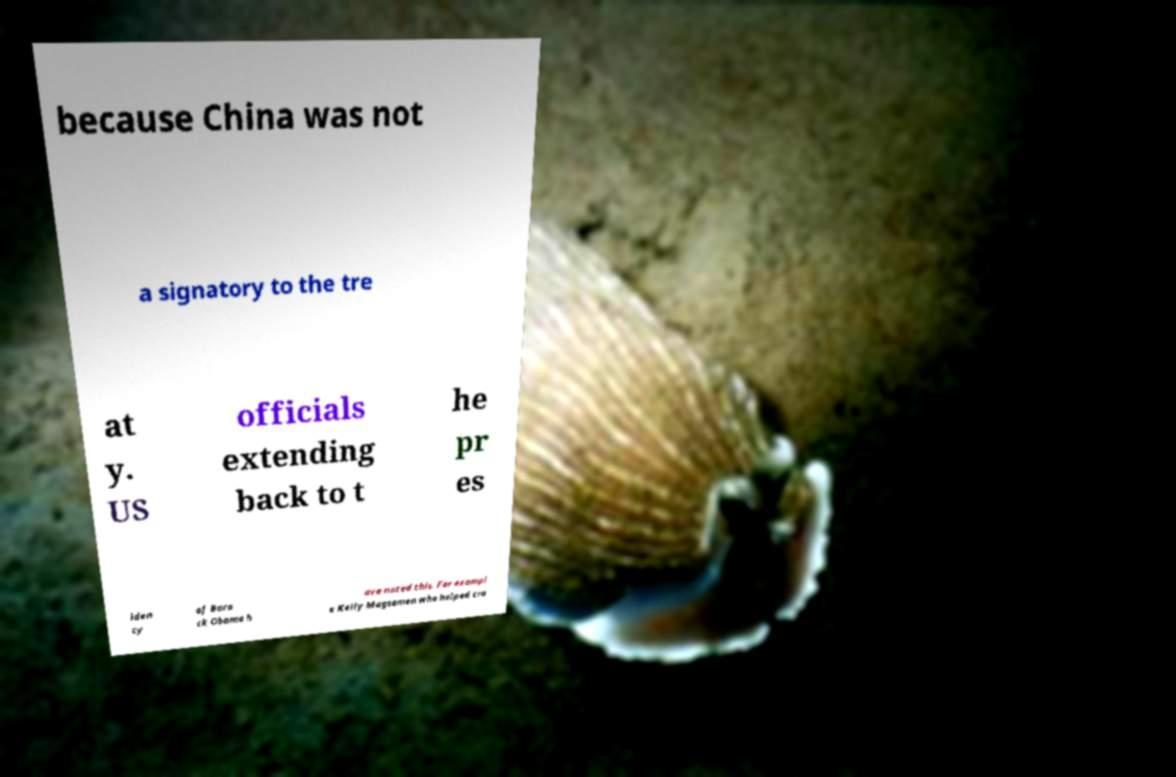Please read and relay the text visible in this image. What does it say? because China was not a signatory to the tre at y. US officials extending back to t he pr es iden cy of Bara ck Obama h ave noted this. For exampl e Kelly Magsamen who helped cra 